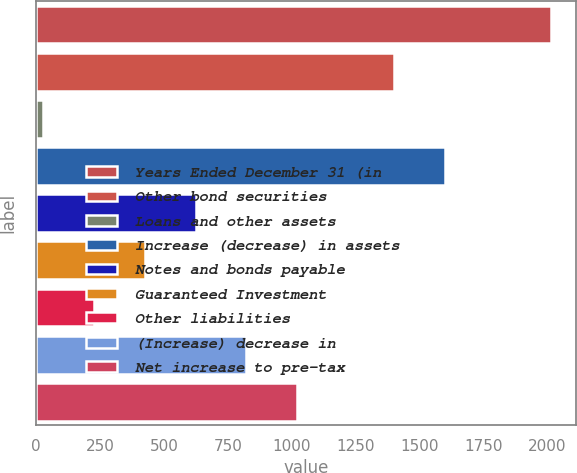Convert chart to OTSL. <chart><loc_0><loc_0><loc_500><loc_500><bar_chart><fcel>Years Ended December 31 (in<fcel>Other bond securities<fcel>Loans and other assets<fcel>Increase (decrease) in assets<fcel>Notes and bonds payable<fcel>Guaranteed Investment<fcel>Other liabilities<fcel>(Increase) decrease in<fcel>Net increase to pre-tax<nl><fcel>2012<fcel>1401<fcel>29<fcel>1599.3<fcel>623.9<fcel>425.6<fcel>227.3<fcel>822.2<fcel>1020.5<nl></chart> 